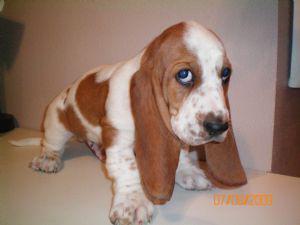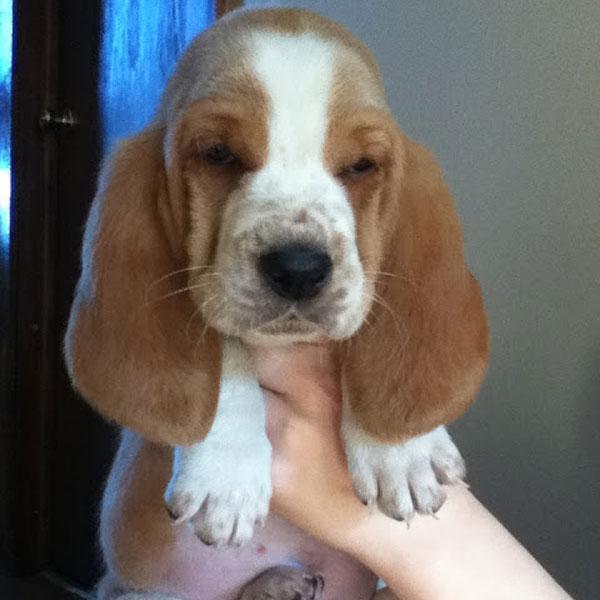The first image is the image on the left, the second image is the image on the right. Considering the images on both sides, is "Each image shows a basset hound, and the hound on the right looks sleepy-eyed." valid? Answer yes or no. Yes. The first image is the image on the left, the second image is the image on the right. For the images shown, is this caption "There is a small puppy with brown floppy ears sitting on white snow." true? Answer yes or no. No. 